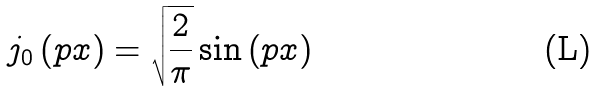<formula> <loc_0><loc_0><loc_500><loc_500>j _ { 0 } \left ( p x \right ) = \sqrt { \frac { 2 } { \pi } } \sin \left ( p x \right )</formula> 